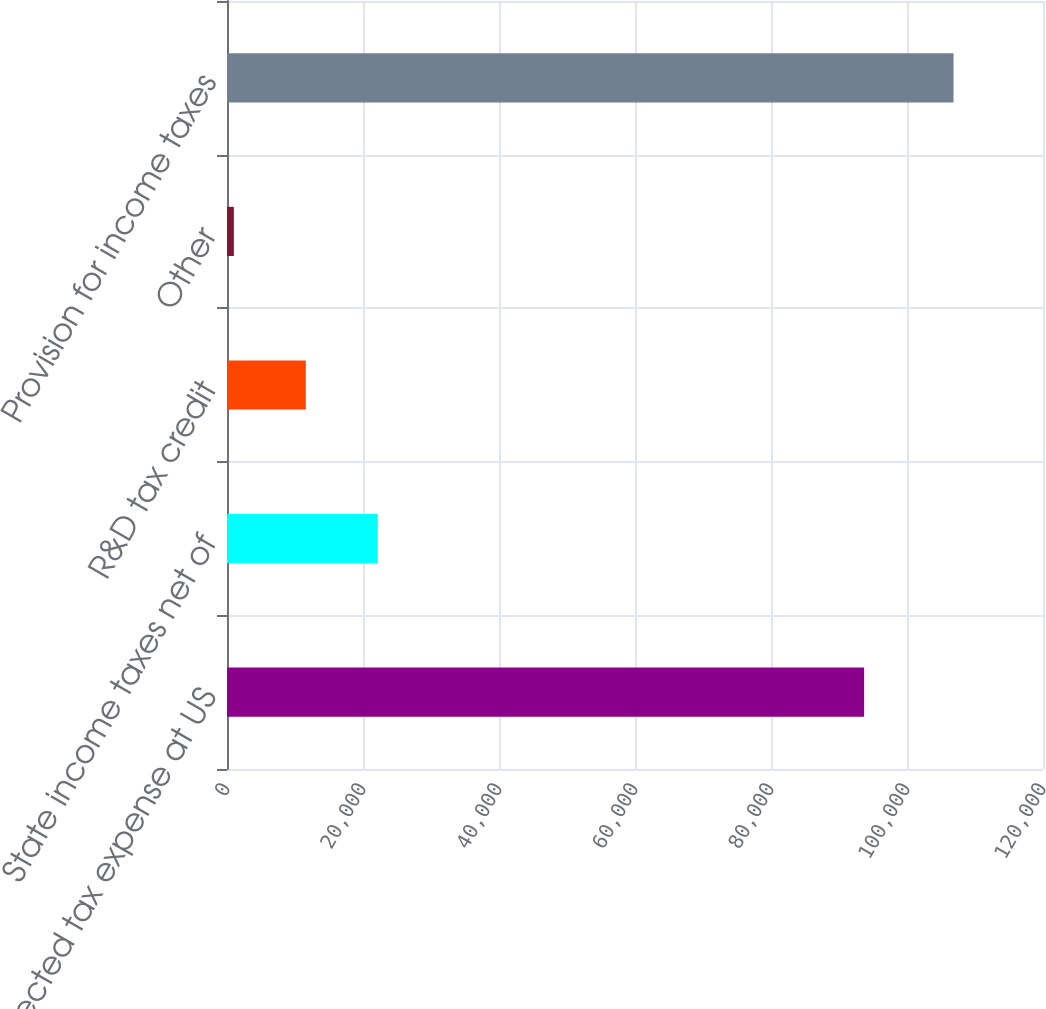<chart> <loc_0><loc_0><loc_500><loc_500><bar_chart><fcel>Expected tax expense at US<fcel>State income taxes net of<fcel>R&D tax credit<fcel>Other<fcel>Provision for income taxes<nl><fcel>93694<fcel>22174.2<fcel>11590.6<fcel>1007<fcel>106843<nl></chart> 